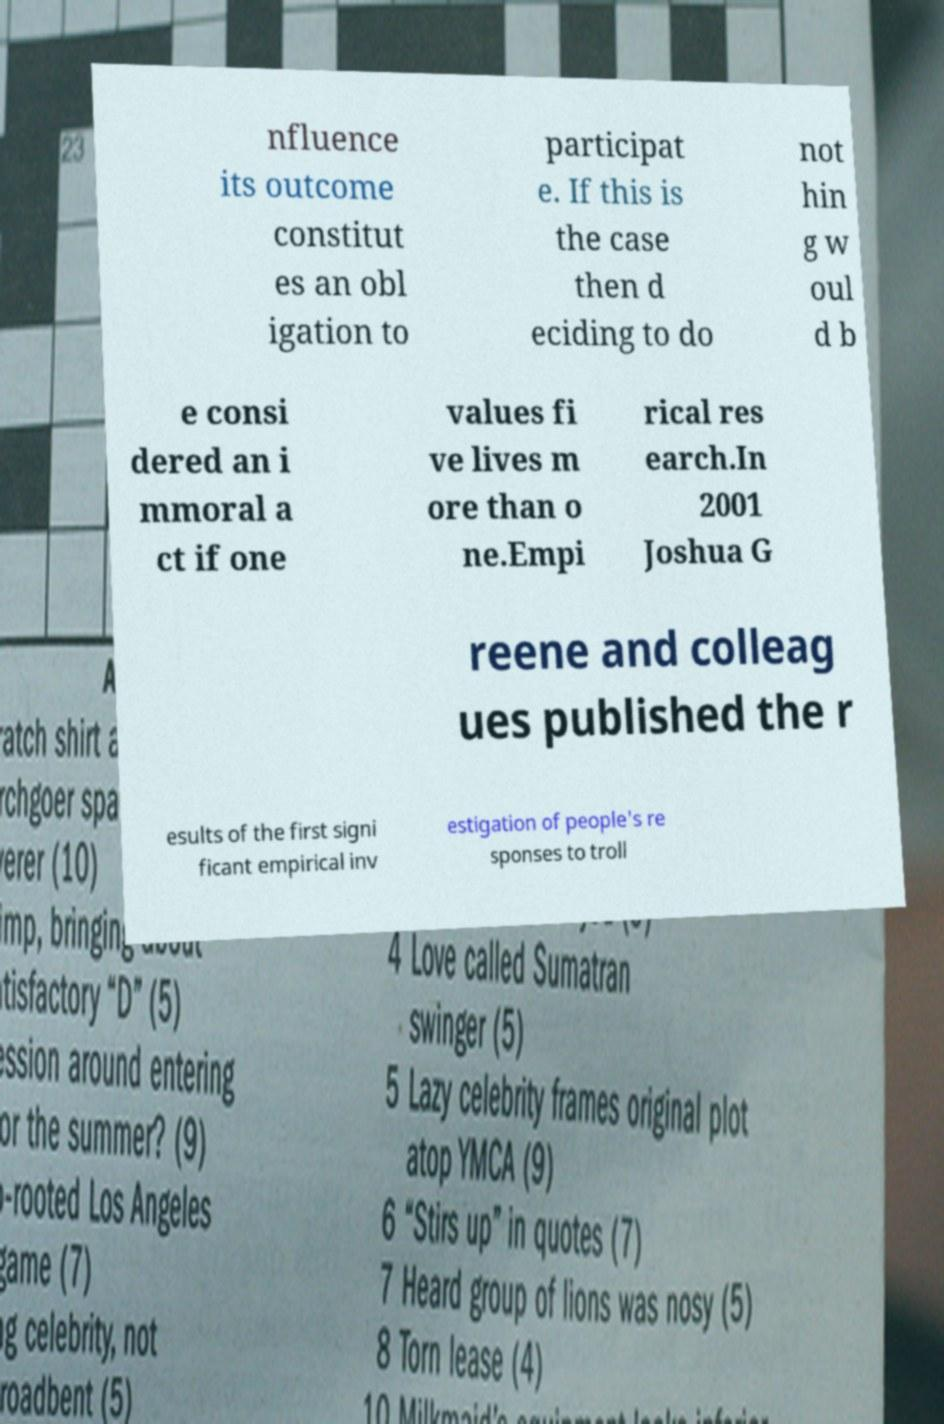Could you extract and type out the text from this image? nfluence its outcome constitut es an obl igation to participat e. If this is the case then d eciding to do not hin g w oul d b e consi dered an i mmoral a ct if one values fi ve lives m ore than o ne.Empi rical res earch.In 2001 Joshua G reene and colleag ues published the r esults of the first signi ficant empirical inv estigation of people's re sponses to troll 